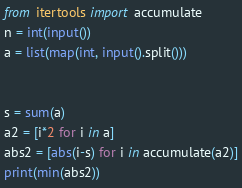<code> <loc_0><loc_0><loc_500><loc_500><_Python_>from itertools import accumulate
n = int(input())
a = list(map(int, input().split()))


s = sum(a)
a2 = [i*2 for i in a]
abs2 = [abs(i-s) for i in accumulate(a2)]
print(min(abs2))</code> 